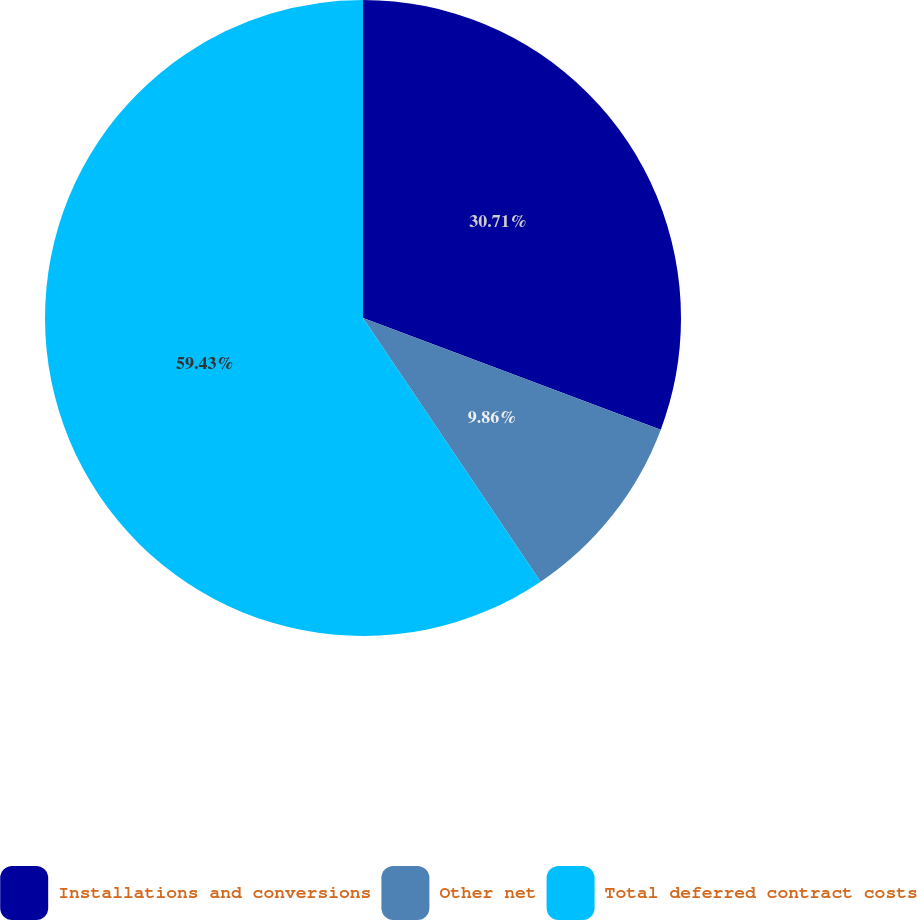<chart> <loc_0><loc_0><loc_500><loc_500><pie_chart><fcel>Installations and conversions<fcel>Other net<fcel>Total deferred contract costs<nl><fcel>30.71%<fcel>9.86%<fcel>59.43%<nl></chart> 